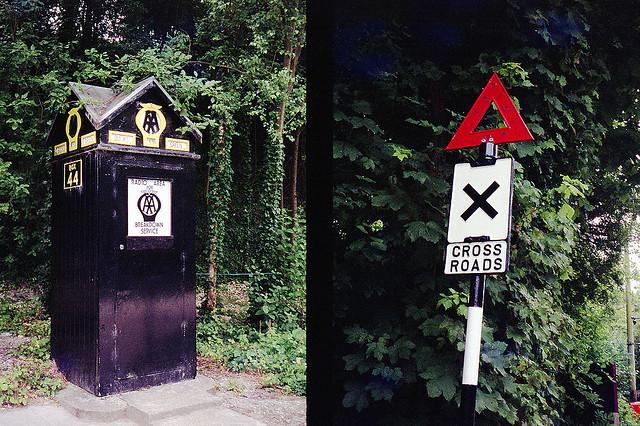What color is the triangle?
Concise answer only. Red. What is the word above roads?
Be succinct. Cross. What is the symbol on the white sign?
Short answer required. X. 